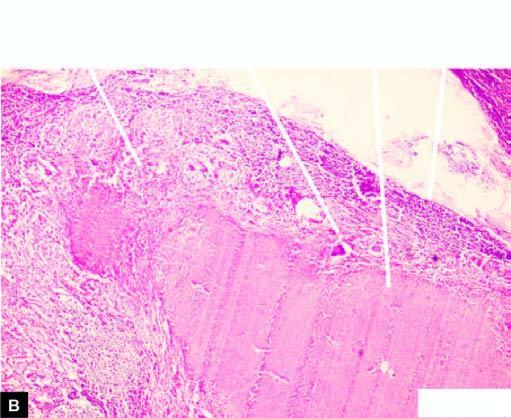does a cut section of matted mass of lymph nodes show merging capsules and large areas of caseation necrosis?
Answer the question using a single word or phrase. Yes 